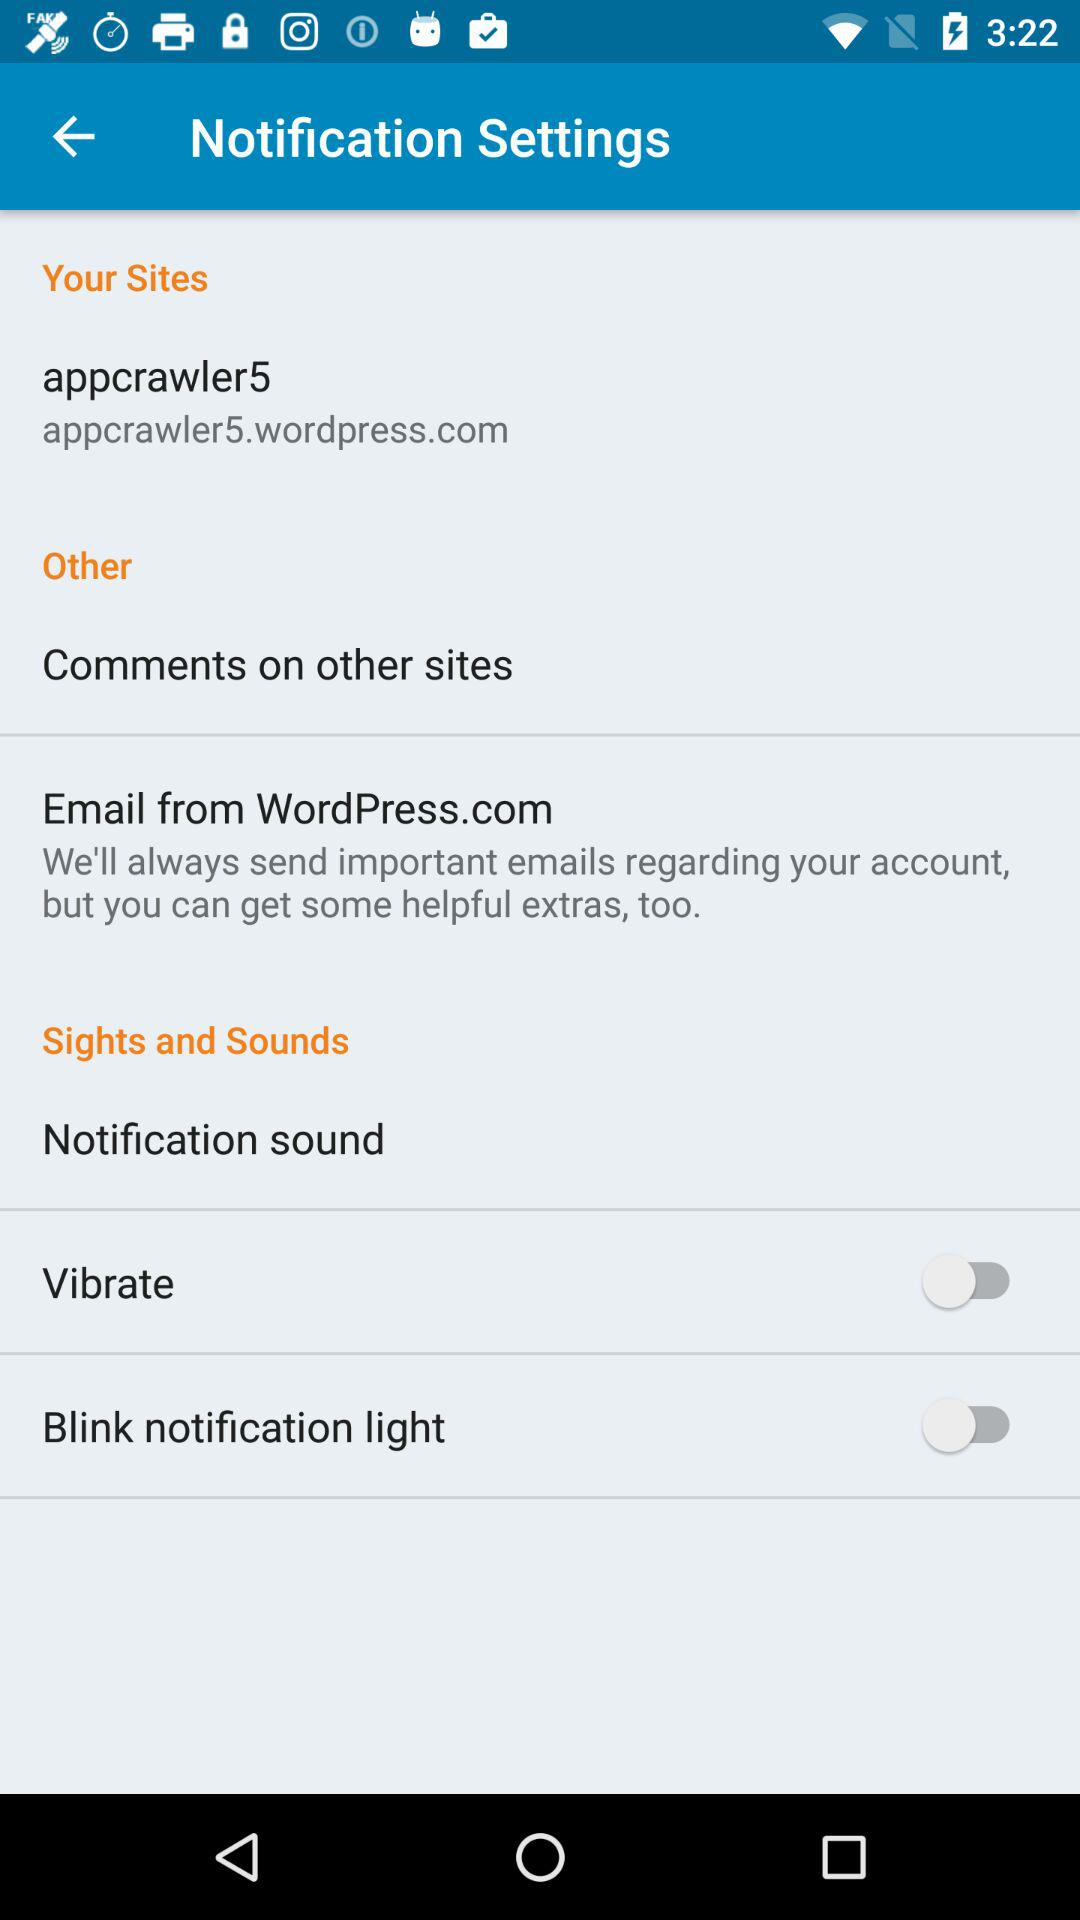How many notification types are there?
Answer the question using a single word or phrase. 3 